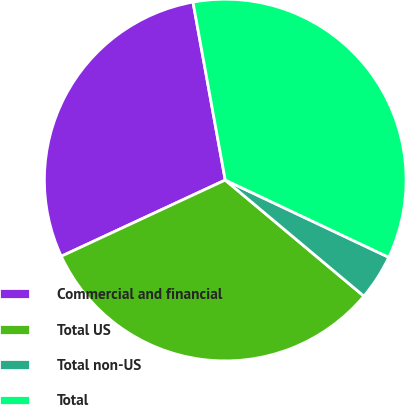Convert chart. <chart><loc_0><loc_0><loc_500><loc_500><pie_chart><fcel>Commercial and financial<fcel>Total US<fcel>Total non-US<fcel>Total<nl><fcel>29.07%<fcel>31.98%<fcel>4.07%<fcel>34.88%<nl></chart> 